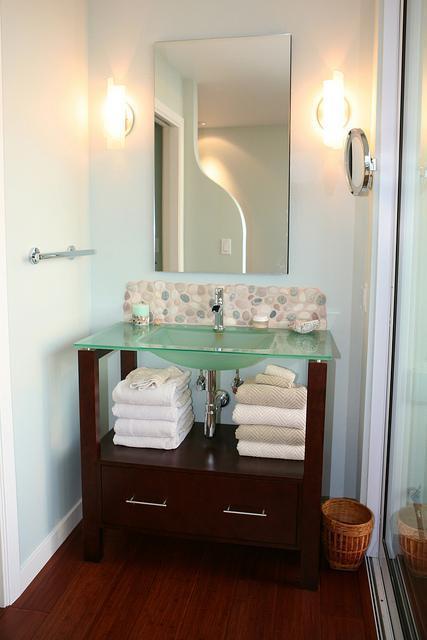How many towels are there?
Give a very brief answer. 8. How many sinks are in the photo?
Give a very brief answer. 1. 